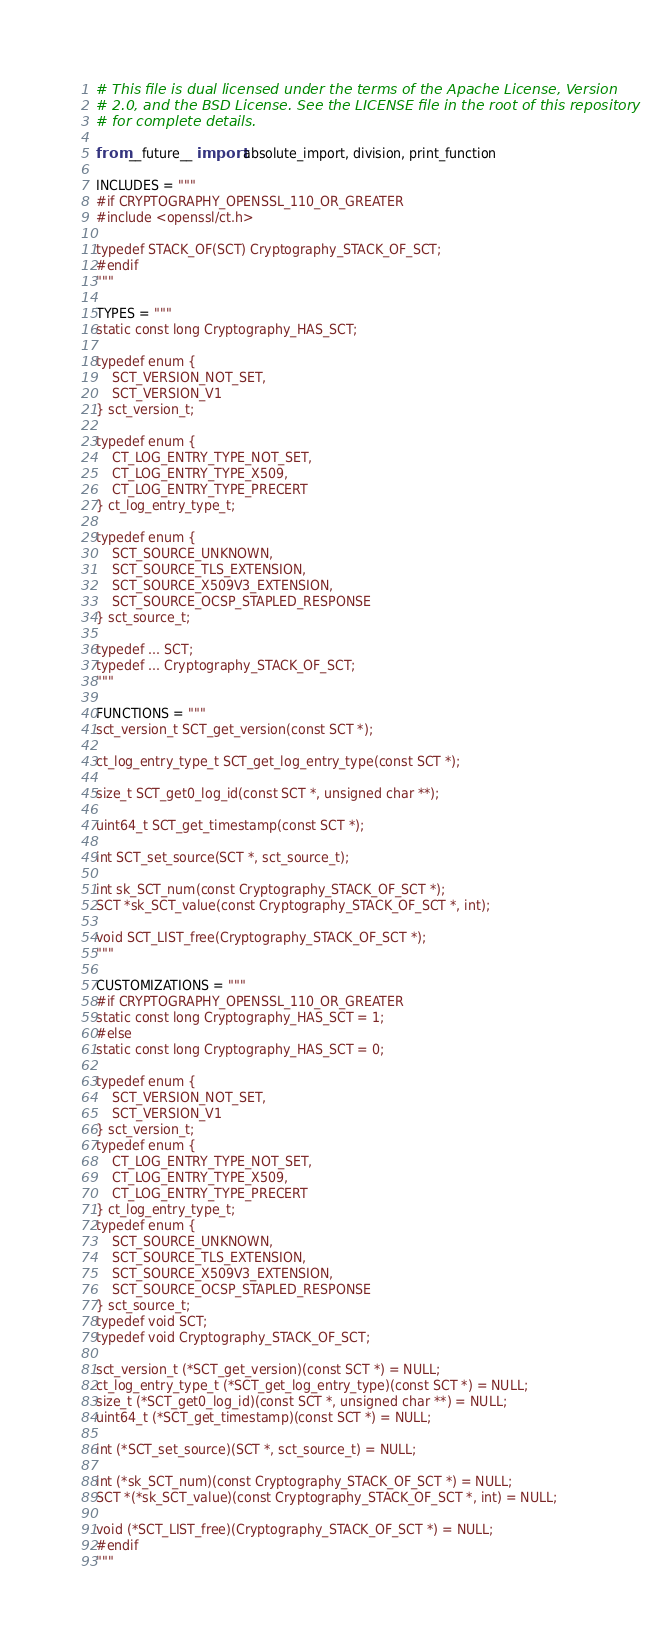Convert code to text. <code><loc_0><loc_0><loc_500><loc_500><_Python_># This file is dual licensed under the terms of the Apache License, Version
# 2.0, and the BSD License. See the LICENSE file in the root of this repository
# for complete details.

from __future__ import absolute_import, division, print_function

INCLUDES = """
#if CRYPTOGRAPHY_OPENSSL_110_OR_GREATER
#include <openssl/ct.h>

typedef STACK_OF(SCT) Cryptography_STACK_OF_SCT;
#endif
"""

TYPES = """
static const long Cryptography_HAS_SCT;

typedef enum {
    SCT_VERSION_NOT_SET,
    SCT_VERSION_V1
} sct_version_t;

typedef enum {
    CT_LOG_ENTRY_TYPE_NOT_SET,
    CT_LOG_ENTRY_TYPE_X509,
    CT_LOG_ENTRY_TYPE_PRECERT
} ct_log_entry_type_t;

typedef enum {
    SCT_SOURCE_UNKNOWN,
    SCT_SOURCE_TLS_EXTENSION,
    SCT_SOURCE_X509V3_EXTENSION,
    SCT_SOURCE_OCSP_STAPLED_RESPONSE
} sct_source_t;

typedef ... SCT;
typedef ... Cryptography_STACK_OF_SCT;
"""

FUNCTIONS = """
sct_version_t SCT_get_version(const SCT *);

ct_log_entry_type_t SCT_get_log_entry_type(const SCT *);

size_t SCT_get0_log_id(const SCT *, unsigned char **);

uint64_t SCT_get_timestamp(const SCT *);

int SCT_set_source(SCT *, sct_source_t);

int sk_SCT_num(const Cryptography_STACK_OF_SCT *);
SCT *sk_SCT_value(const Cryptography_STACK_OF_SCT *, int);

void SCT_LIST_free(Cryptography_STACK_OF_SCT *);
"""

CUSTOMIZATIONS = """
#if CRYPTOGRAPHY_OPENSSL_110_OR_GREATER
static const long Cryptography_HAS_SCT = 1;
#else
static const long Cryptography_HAS_SCT = 0;

typedef enum {
    SCT_VERSION_NOT_SET,
    SCT_VERSION_V1
} sct_version_t;
typedef enum {
    CT_LOG_ENTRY_TYPE_NOT_SET,
    CT_LOG_ENTRY_TYPE_X509,
    CT_LOG_ENTRY_TYPE_PRECERT
} ct_log_entry_type_t;
typedef enum {
    SCT_SOURCE_UNKNOWN,
    SCT_SOURCE_TLS_EXTENSION,
    SCT_SOURCE_X509V3_EXTENSION,
    SCT_SOURCE_OCSP_STAPLED_RESPONSE
} sct_source_t;
typedef void SCT;
typedef void Cryptography_STACK_OF_SCT;

sct_version_t (*SCT_get_version)(const SCT *) = NULL;
ct_log_entry_type_t (*SCT_get_log_entry_type)(const SCT *) = NULL;
size_t (*SCT_get0_log_id)(const SCT *, unsigned char **) = NULL;
uint64_t (*SCT_get_timestamp)(const SCT *) = NULL;

int (*SCT_set_source)(SCT *, sct_source_t) = NULL;

int (*sk_SCT_num)(const Cryptography_STACK_OF_SCT *) = NULL;
SCT *(*sk_SCT_value)(const Cryptography_STACK_OF_SCT *, int) = NULL;

void (*SCT_LIST_free)(Cryptography_STACK_OF_SCT *) = NULL;
#endif
"""
</code> 